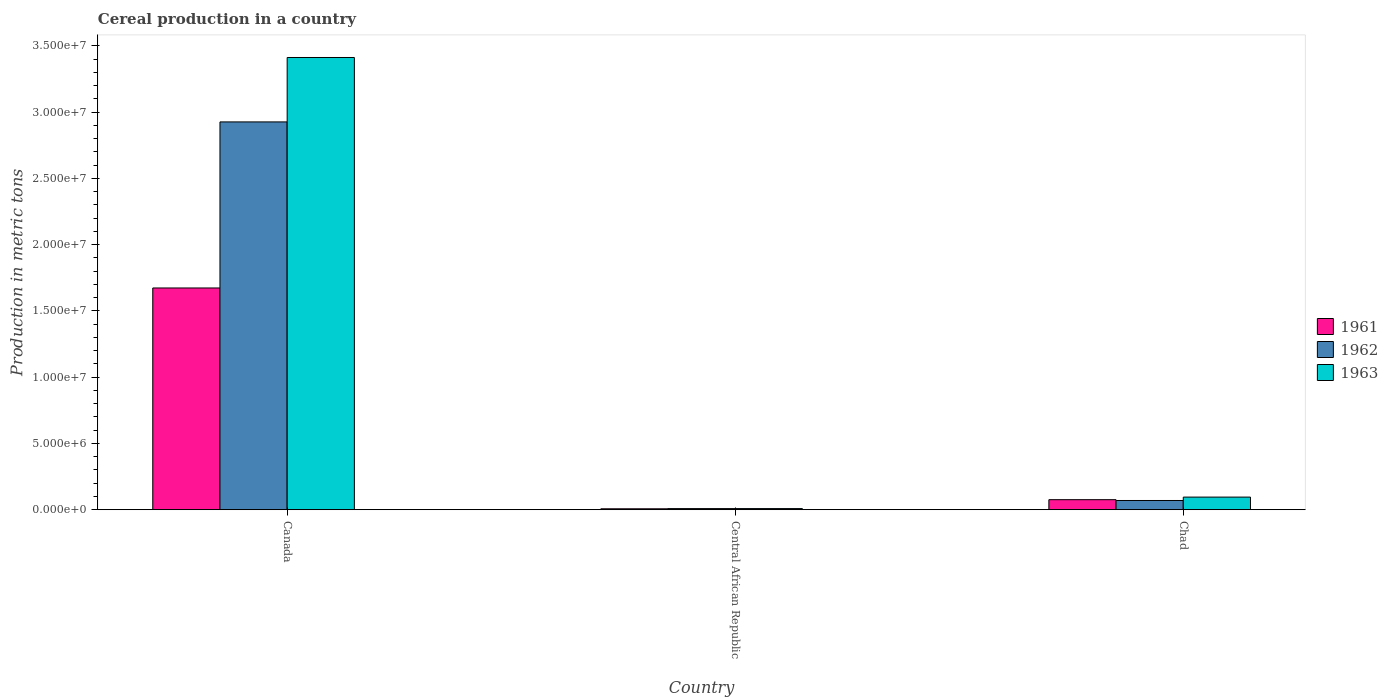How many different coloured bars are there?
Your answer should be very brief. 3. How many groups of bars are there?
Offer a terse response. 3. Are the number of bars per tick equal to the number of legend labels?
Provide a succinct answer. Yes. How many bars are there on the 2nd tick from the left?
Provide a short and direct response. 3. In how many cases, is the number of bars for a given country not equal to the number of legend labels?
Your response must be concise. 0. What is the total cereal production in 1962 in Canada?
Give a very brief answer. 2.93e+07. Across all countries, what is the maximum total cereal production in 1961?
Give a very brief answer. 1.67e+07. Across all countries, what is the minimum total cereal production in 1962?
Give a very brief answer. 8.33e+04. In which country was the total cereal production in 1961 maximum?
Your answer should be very brief. Canada. In which country was the total cereal production in 1961 minimum?
Offer a very short reply. Central African Republic. What is the total total cereal production in 1963 in the graph?
Your response must be concise. 3.52e+07. What is the difference between the total cereal production in 1963 in Canada and that in Chad?
Provide a succinct answer. 3.32e+07. What is the difference between the total cereal production in 1963 in Chad and the total cereal production in 1961 in Central African Republic?
Keep it short and to the point. 8.82e+05. What is the average total cereal production in 1962 per country?
Offer a terse response. 1.00e+07. What is the difference between the total cereal production of/in 1963 and total cereal production of/in 1961 in Canada?
Keep it short and to the point. 1.74e+07. In how many countries, is the total cereal production in 1962 greater than 6000000 metric tons?
Your response must be concise. 1. What is the ratio of the total cereal production in 1961 in Central African Republic to that in Chad?
Keep it short and to the point. 0.09. Is the total cereal production in 1961 in Central African Republic less than that in Chad?
Offer a terse response. Yes. Is the difference between the total cereal production in 1963 in Central African Republic and Chad greater than the difference between the total cereal production in 1961 in Central African Republic and Chad?
Keep it short and to the point. No. What is the difference between the highest and the second highest total cereal production in 1961?
Provide a succinct answer. -1.60e+07. What is the difference between the highest and the lowest total cereal production in 1962?
Give a very brief answer. 2.92e+07. In how many countries, is the total cereal production in 1961 greater than the average total cereal production in 1961 taken over all countries?
Your answer should be compact. 1. Is the sum of the total cereal production in 1963 in Canada and Central African Republic greater than the maximum total cereal production in 1961 across all countries?
Your answer should be very brief. Yes. What does the 2nd bar from the left in Central African Republic represents?
Your answer should be compact. 1962. Is it the case that in every country, the sum of the total cereal production in 1962 and total cereal production in 1961 is greater than the total cereal production in 1963?
Your answer should be compact. Yes. How many countries are there in the graph?
Your answer should be compact. 3. Does the graph contain any zero values?
Provide a short and direct response. No. Does the graph contain grids?
Provide a short and direct response. No. How many legend labels are there?
Make the answer very short. 3. How are the legend labels stacked?
Make the answer very short. Vertical. What is the title of the graph?
Provide a succinct answer. Cereal production in a country. Does "1974" appear as one of the legend labels in the graph?
Provide a succinct answer. No. What is the label or title of the X-axis?
Your answer should be very brief. Country. What is the label or title of the Y-axis?
Give a very brief answer. Production in metric tons. What is the Production in metric tons of 1961 in Canada?
Offer a terse response. 1.67e+07. What is the Production in metric tons in 1962 in Canada?
Keep it short and to the point. 2.93e+07. What is the Production in metric tons of 1963 in Canada?
Your answer should be very brief. 3.41e+07. What is the Production in metric tons of 1961 in Central African Republic?
Your response must be concise. 6.80e+04. What is the Production in metric tons of 1962 in Central African Republic?
Provide a short and direct response. 8.33e+04. What is the Production in metric tons of 1963 in Central African Republic?
Ensure brevity in your answer.  8.43e+04. What is the Production in metric tons of 1961 in Chad?
Give a very brief answer. 7.56e+05. What is the Production in metric tons in 1962 in Chad?
Provide a succinct answer. 6.95e+05. What is the Production in metric tons of 1963 in Chad?
Keep it short and to the point. 9.50e+05. Across all countries, what is the maximum Production in metric tons of 1961?
Your response must be concise. 1.67e+07. Across all countries, what is the maximum Production in metric tons in 1962?
Your answer should be compact. 2.93e+07. Across all countries, what is the maximum Production in metric tons of 1963?
Provide a succinct answer. 3.41e+07. Across all countries, what is the minimum Production in metric tons of 1961?
Offer a very short reply. 6.80e+04. Across all countries, what is the minimum Production in metric tons in 1962?
Offer a very short reply. 8.33e+04. Across all countries, what is the minimum Production in metric tons of 1963?
Your answer should be compact. 8.43e+04. What is the total Production in metric tons of 1961 in the graph?
Provide a short and direct response. 1.76e+07. What is the total Production in metric tons in 1962 in the graph?
Make the answer very short. 3.00e+07. What is the total Production in metric tons in 1963 in the graph?
Offer a terse response. 3.52e+07. What is the difference between the Production in metric tons of 1961 in Canada and that in Central African Republic?
Provide a succinct answer. 1.67e+07. What is the difference between the Production in metric tons in 1962 in Canada and that in Central African Republic?
Make the answer very short. 2.92e+07. What is the difference between the Production in metric tons of 1963 in Canada and that in Central African Republic?
Your response must be concise. 3.40e+07. What is the difference between the Production in metric tons of 1961 in Canada and that in Chad?
Keep it short and to the point. 1.60e+07. What is the difference between the Production in metric tons of 1962 in Canada and that in Chad?
Give a very brief answer. 2.86e+07. What is the difference between the Production in metric tons of 1963 in Canada and that in Chad?
Offer a terse response. 3.32e+07. What is the difference between the Production in metric tons in 1961 in Central African Republic and that in Chad?
Your answer should be compact. -6.88e+05. What is the difference between the Production in metric tons in 1962 in Central African Republic and that in Chad?
Keep it short and to the point. -6.12e+05. What is the difference between the Production in metric tons in 1963 in Central African Republic and that in Chad?
Your response must be concise. -8.66e+05. What is the difference between the Production in metric tons of 1961 in Canada and the Production in metric tons of 1962 in Central African Republic?
Provide a succinct answer. 1.66e+07. What is the difference between the Production in metric tons of 1961 in Canada and the Production in metric tons of 1963 in Central African Republic?
Make the answer very short. 1.66e+07. What is the difference between the Production in metric tons of 1962 in Canada and the Production in metric tons of 1963 in Central African Republic?
Provide a succinct answer. 2.92e+07. What is the difference between the Production in metric tons in 1961 in Canada and the Production in metric tons in 1962 in Chad?
Provide a succinct answer. 1.60e+07. What is the difference between the Production in metric tons of 1961 in Canada and the Production in metric tons of 1963 in Chad?
Offer a very short reply. 1.58e+07. What is the difference between the Production in metric tons in 1962 in Canada and the Production in metric tons in 1963 in Chad?
Give a very brief answer. 2.83e+07. What is the difference between the Production in metric tons of 1961 in Central African Republic and the Production in metric tons of 1962 in Chad?
Offer a very short reply. -6.27e+05. What is the difference between the Production in metric tons in 1961 in Central African Republic and the Production in metric tons in 1963 in Chad?
Provide a succinct answer. -8.82e+05. What is the difference between the Production in metric tons of 1962 in Central African Republic and the Production in metric tons of 1963 in Chad?
Your answer should be very brief. -8.67e+05. What is the average Production in metric tons of 1961 per country?
Provide a short and direct response. 5.85e+06. What is the average Production in metric tons of 1962 per country?
Give a very brief answer. 1.00e+07. What is the average Production in metric tons in 1963 per country?
Offer a very short reply. 1.17e+07. What is the difference between the Production in metric tons in 1961 and Production in metric tons in 1962 in Canada?
Make the answer very short. -1.25e+07. What is the difference between the Production in metric tons in 1961 and Production in metric tons in 1963 in Canada?
Offer a terse response. -1.74e+07. What is the difference between the Production in metric tons in 1962 and Production in metric tons in 1963 in Canada?
Ensure brevity in your answer.  -4.86e+06. What is the difference between the Production in metric tons of 1961 and Production in metric tons of 1962 in Central African Republic?
Provide a short and direct response. -1.53e+04. What is the difference between the Production in metric tons of 1961 and Production in metric tons of 1963 in Central African Republic?
Keep it short and to the point. -1.63e+04. What is the difference between the Production in metric tons in 1962 and Production in metric tons in 1963 in Central African Republic?
Give a very brief answer. -1000. What is the difference between the Production in metric tons of 1961 and Production in metric tons of 1962 in Chad?
Provide a succinct answer. 6.05e+04. What is the difference between the Production in metric tons of 1961 and Production in metric tons of 1963 in Chad?
Keep it short and to the point. -1.94e+05. What is the difference between the Production in metric tons in 1962 and Production in metric tons in 1963 in Chad?
Ensure brevity in your answer.  -2.55e+05. What is the ratio of the Production in metric tons in 1961 in Canada to that in Central African Republic?
Provide a short and direct response. 246.03. What is the ratio of the Production in metric tons in 1962 in Canada to that in Central African Republic?
Make the answer very short. 351.28. What is the ratio of the Production in metric tons in 1963 in Canada to that in Central African Republic?
Your response must be concise. 404.77. What is the ratio of the Production in metric tons in 1961 in Canada to that in Chad?
Make the answer very short. 22.14. What is the ratio of the Production in metric tons in 1962 in Canada to that in Chad?
Ensure brevity in your answer.  42.1. What is the ratio of the Production in metric tons of 1963 in Canada to that in Chad?
Your answer should be very brief. 35.92. What is the ratio of the Production in metric tons of 1961 in Central African Republic to that in Chad?
Provide a short and direct response. 0.09. What is the ratio of the Production in metric tons in 1962 in Central African Republic to that in Chad?
Offer a very short reply. 0.12. What is the ratio of the Production in metric tons of 1963 in Central African Republic to that in Chad?
Offer a very short reply. 0.09. What is the difference between the highest and the second highest Production in metric tons in 1961?
Offer a terse response. 1.60e+07. What is the difference between the highest and the second highest Production in metric tons in 1962?
Your answer should be compact. 2.86e+07. What is the difference between the highest and the second highest Production in metric tons in 1963?
Your response must be concise. 3.32e+07. What is the difference between the highest and the lowest Production in metric tons of 1961?
Provide a short and direct response. 1.67e+07. What is the difference between the highest and the lowest Production in metric tons of 1962?
Make the answer very short. 2.92e+07. What is the difference between the highest and the lowest Production in metric tons in 1963?
Give a very brief answer. 3.40e+07. 